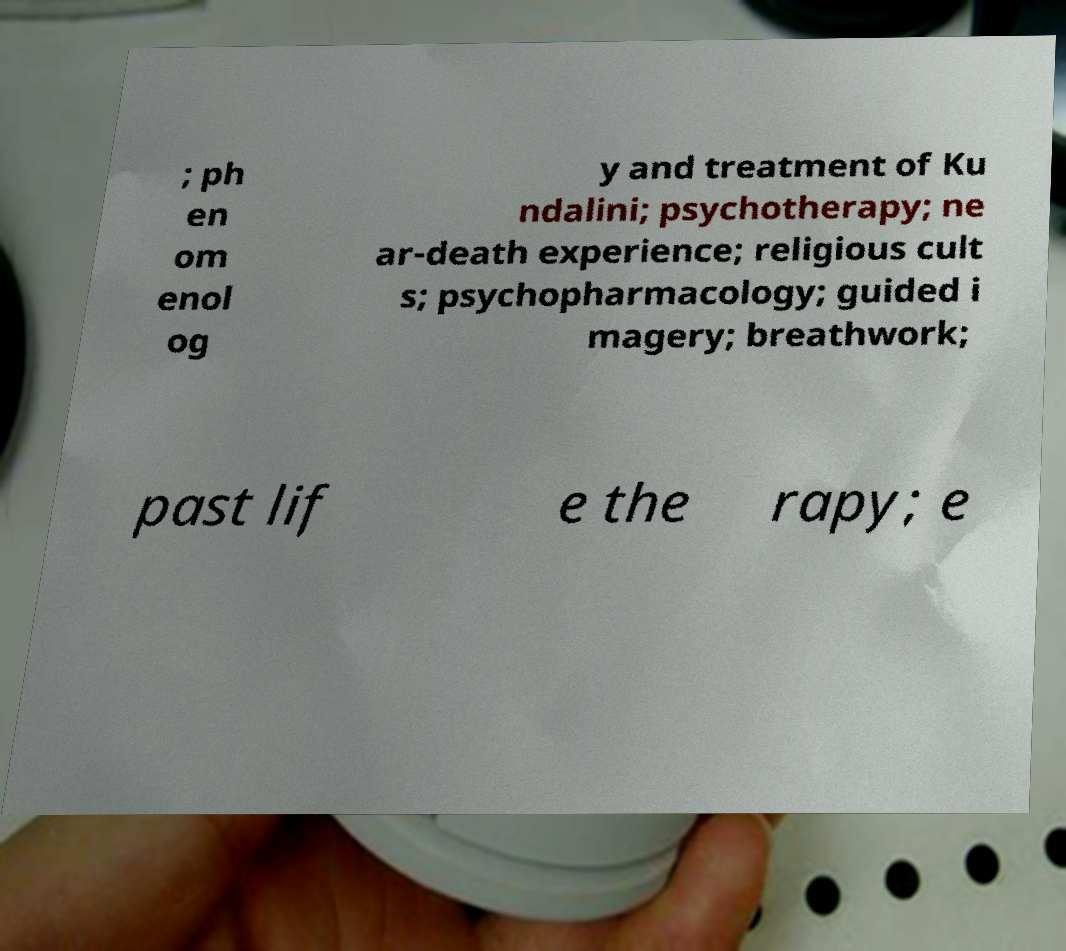I need the written content from this picture converted into text. Can you do that? ; ph en om enol og y and treatment of Ku ndalini; psychotherapy; ne ar-death experience; religious cult s; psychopharmacology; guided i magery; breathwork; past lif e the rapy; e 